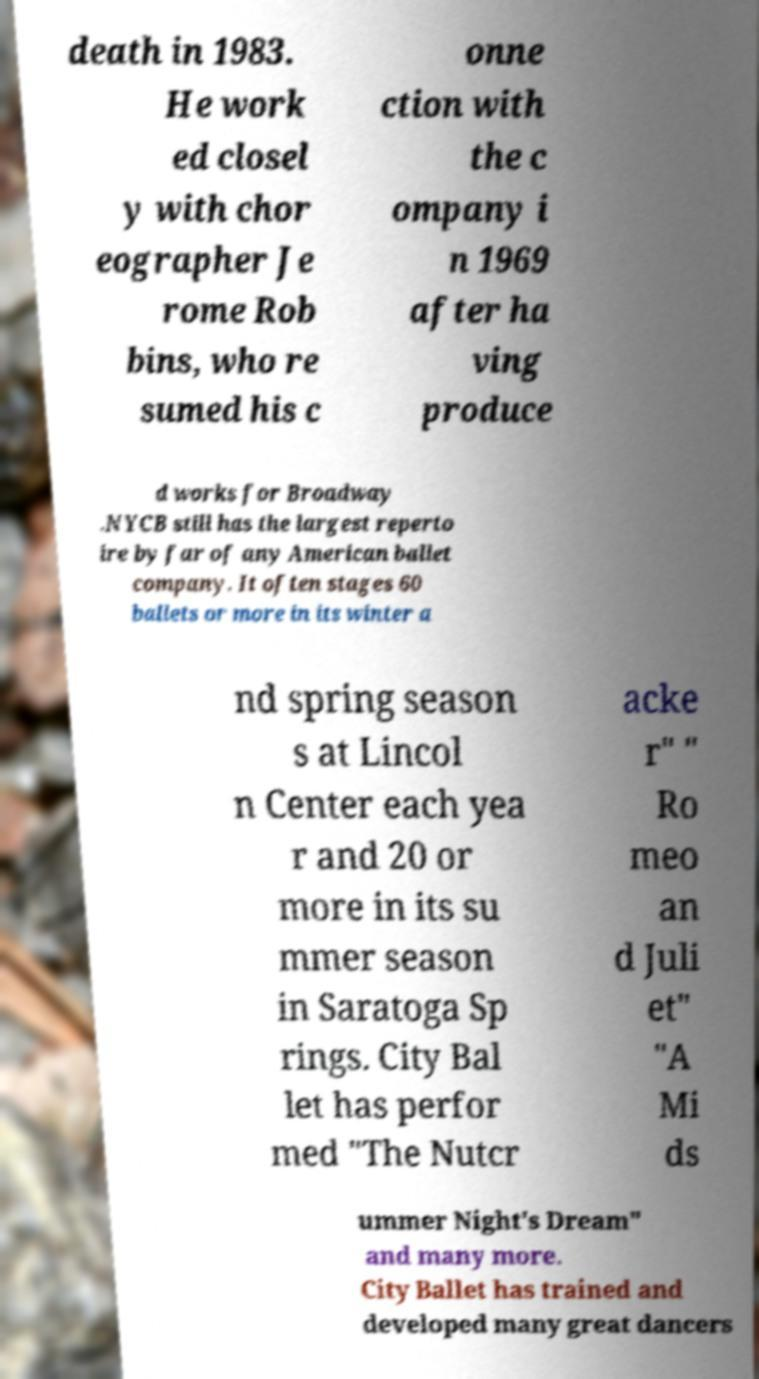For documentation purposes, I need the text within this image transcribed. Could you provide that? death in 1983. He work ed closel y with chor eographer Je rome Rob bins, who re sumed his c onne ction with the c ompany i n 1969 after ha ving produce d works for Broadway .NYCB still has the largest reperto ire by far of any American ballet company. It often stages 60 ballets or more in its winter a nd spring season s at Lincol n Center each yea r and 20 or more in its su mmer season in Saratoga Sp rings. City Bal let has perfor med "The Nutcr acke r" " Ro meo an d Juli et" "A Mi ds ummer Night's Dream" and many more. City Ballet has trained and developed many great dancers 